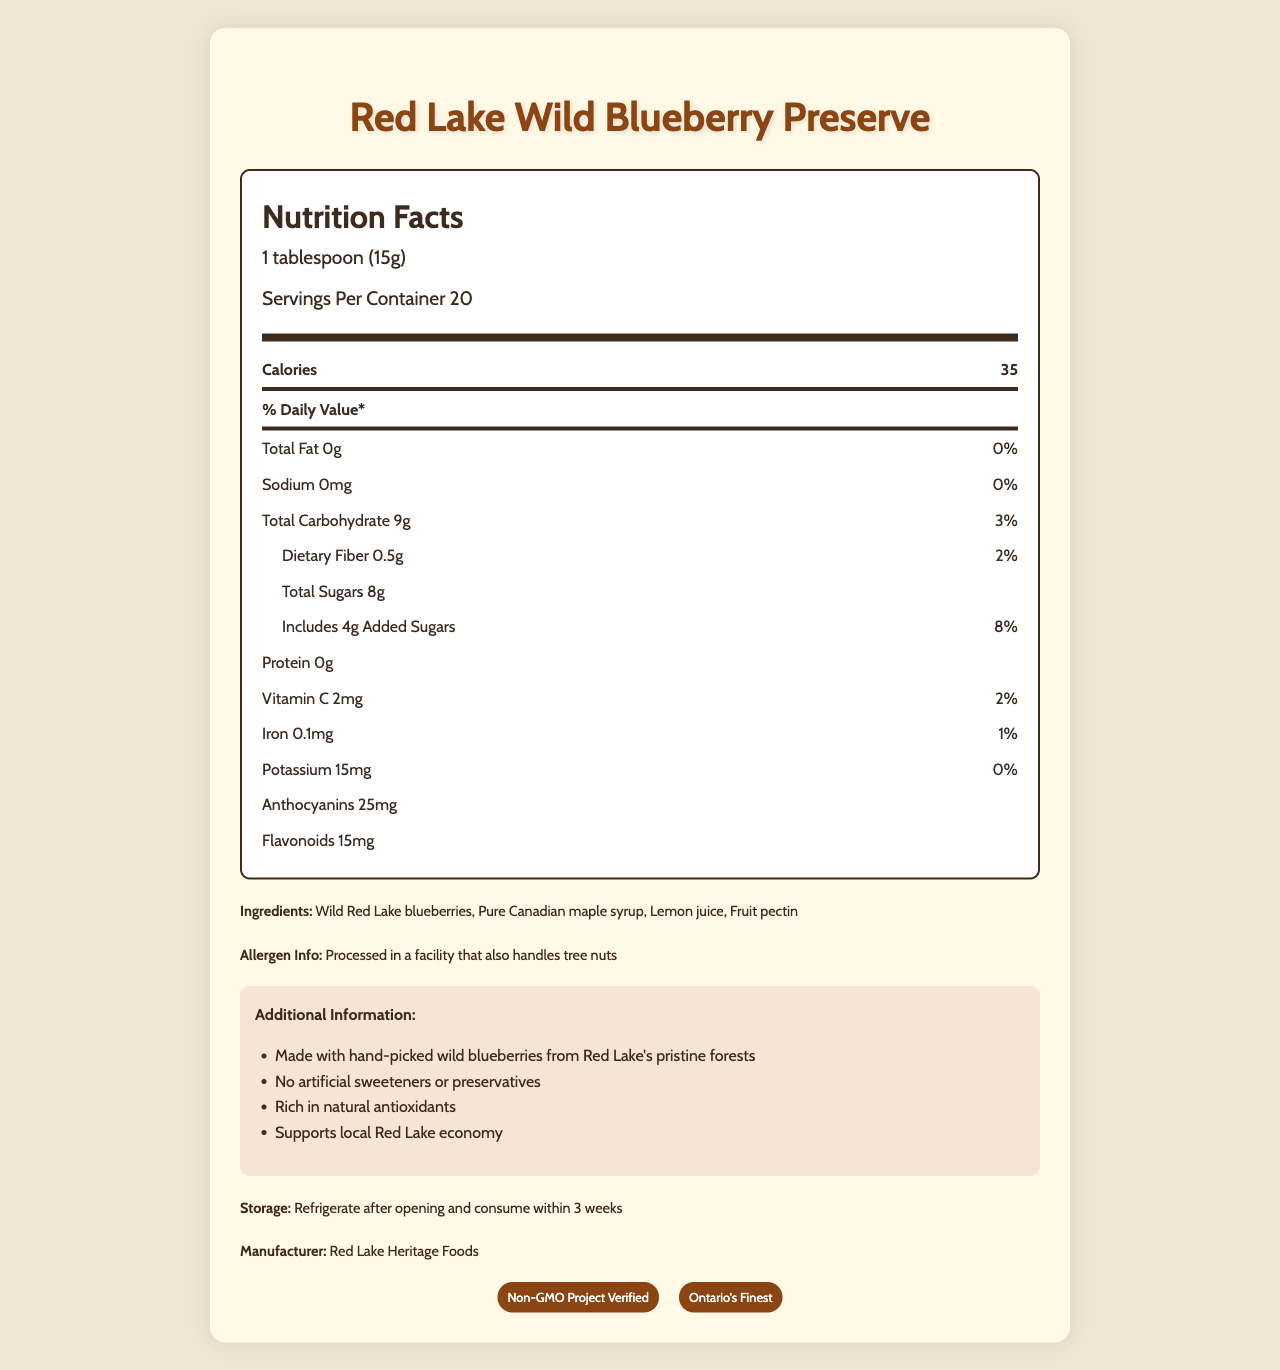what is the serving size for the Red Lake Wild Blueberry Preserve? The document specifies that the serving size is 1 tablespoon (15g).
Answer: 1 tablespoon (15g) how many calories are in one serving of the preserve? The document indicates that each serving of the preserve contains 35 calories.
Answer: 35 what are the total sugars in one serving, and how much of it is added sugars? The nutrition facts state that there are 8g of total sugars and 4g of added sugars per serving.
Answer: 8g total sugars, 4g added sugars how much dietary fiber does one serving contain? The nutritional information shows that there is 0.5g of dietary fiber per serving.
Answer: 0.5g how much vitamin C is present in one serving, and what is its daily value percentage? The document states that each serving contains 2mg of vitamin C which is 2% of the daily value.
Answer: 2mg, 2% which ingredient is listed first in the preserve? The ingredient list starts with "Wild Red Lake blueberries," indicating they are the primary ingredient.
Answer: Wild Red Lake blueberries where is the product processed in terms of allergen information? The allergen information specifies that the product is processed in a facility that also handles tree nuts.
Answer: A facility that also handles tree nuts what certifications does the Red Lake Wild Blueberry Preserve have? The document lists that the product is certified as Non-GMO Project Verified and Ontario's Finest.
Answer: Non-GMO Project Verified, Ontario's Finest what is the recommended storage instruction for the preserve? The storage instructions recommend refrigerating the product after opening and consuming it within 3 weeks.
Answer: Refrigerate after opening and consume within 3 weeks how much potassium is in one serving and what is its daily value percentage? The nutritional information shows that one serving contains 15mg of potassium with a 0% daily value.
Answer: 15mg, 0% what is the main sweetener used in this preserve? A. Sugar B. Honey C. Pure Canadian maple syrup D. Brown sugar The ingredient list indicates that the preserve is sweetened with Pure Canadian maple syrup.
Answer: C what is the daily value percentage of iron per serving? A. 1% B. 2% C. 8% D. 10% The document shows that each serving has 0.1mg of iron, which is 1% of the daily value.
Answer: A does this product contain artificial sweeteners or preservatives? The additional information section states that the product has no artificial sweeteners or preservatives.
Answer: No is the preserve high in antioxidants? The label highlights that the preserve is rich in natural antioxidants, specifically anthocyanins (25mg) and flavonoids (15mg).
Answer: Yes who is the manufacturer of the Red Lake Wild Blueberry Preserve? The document specifies that the manufacturer is Red Lake Heritage Foods.
Answer: Red Lake Heritage Foods describe the main ideas presented in the document. This document provides comprehensive nutritional information, ingredient details, and additional facts about the Red Lake Wild Blueberry Preserve, emphasizing its natural composition and antioxidant content.
Answer: The document is a nutritional facts label for Red Lake Wild Blueberry Preserve. It details serving size, calorie content, and nutritional information such as total fats, carbohydrates, sugars, fibers, proteins, vitamins, and antioxidants. It lists ingredients, allergen info, storage instructions, additional information emphasizing natural ingredients and local economic support, and certifications. what is the price of the Red Lake Wild Blueberry Preserve? The document does not include any pricing information, so the price cannot be determined.
Answer: Not enough information 